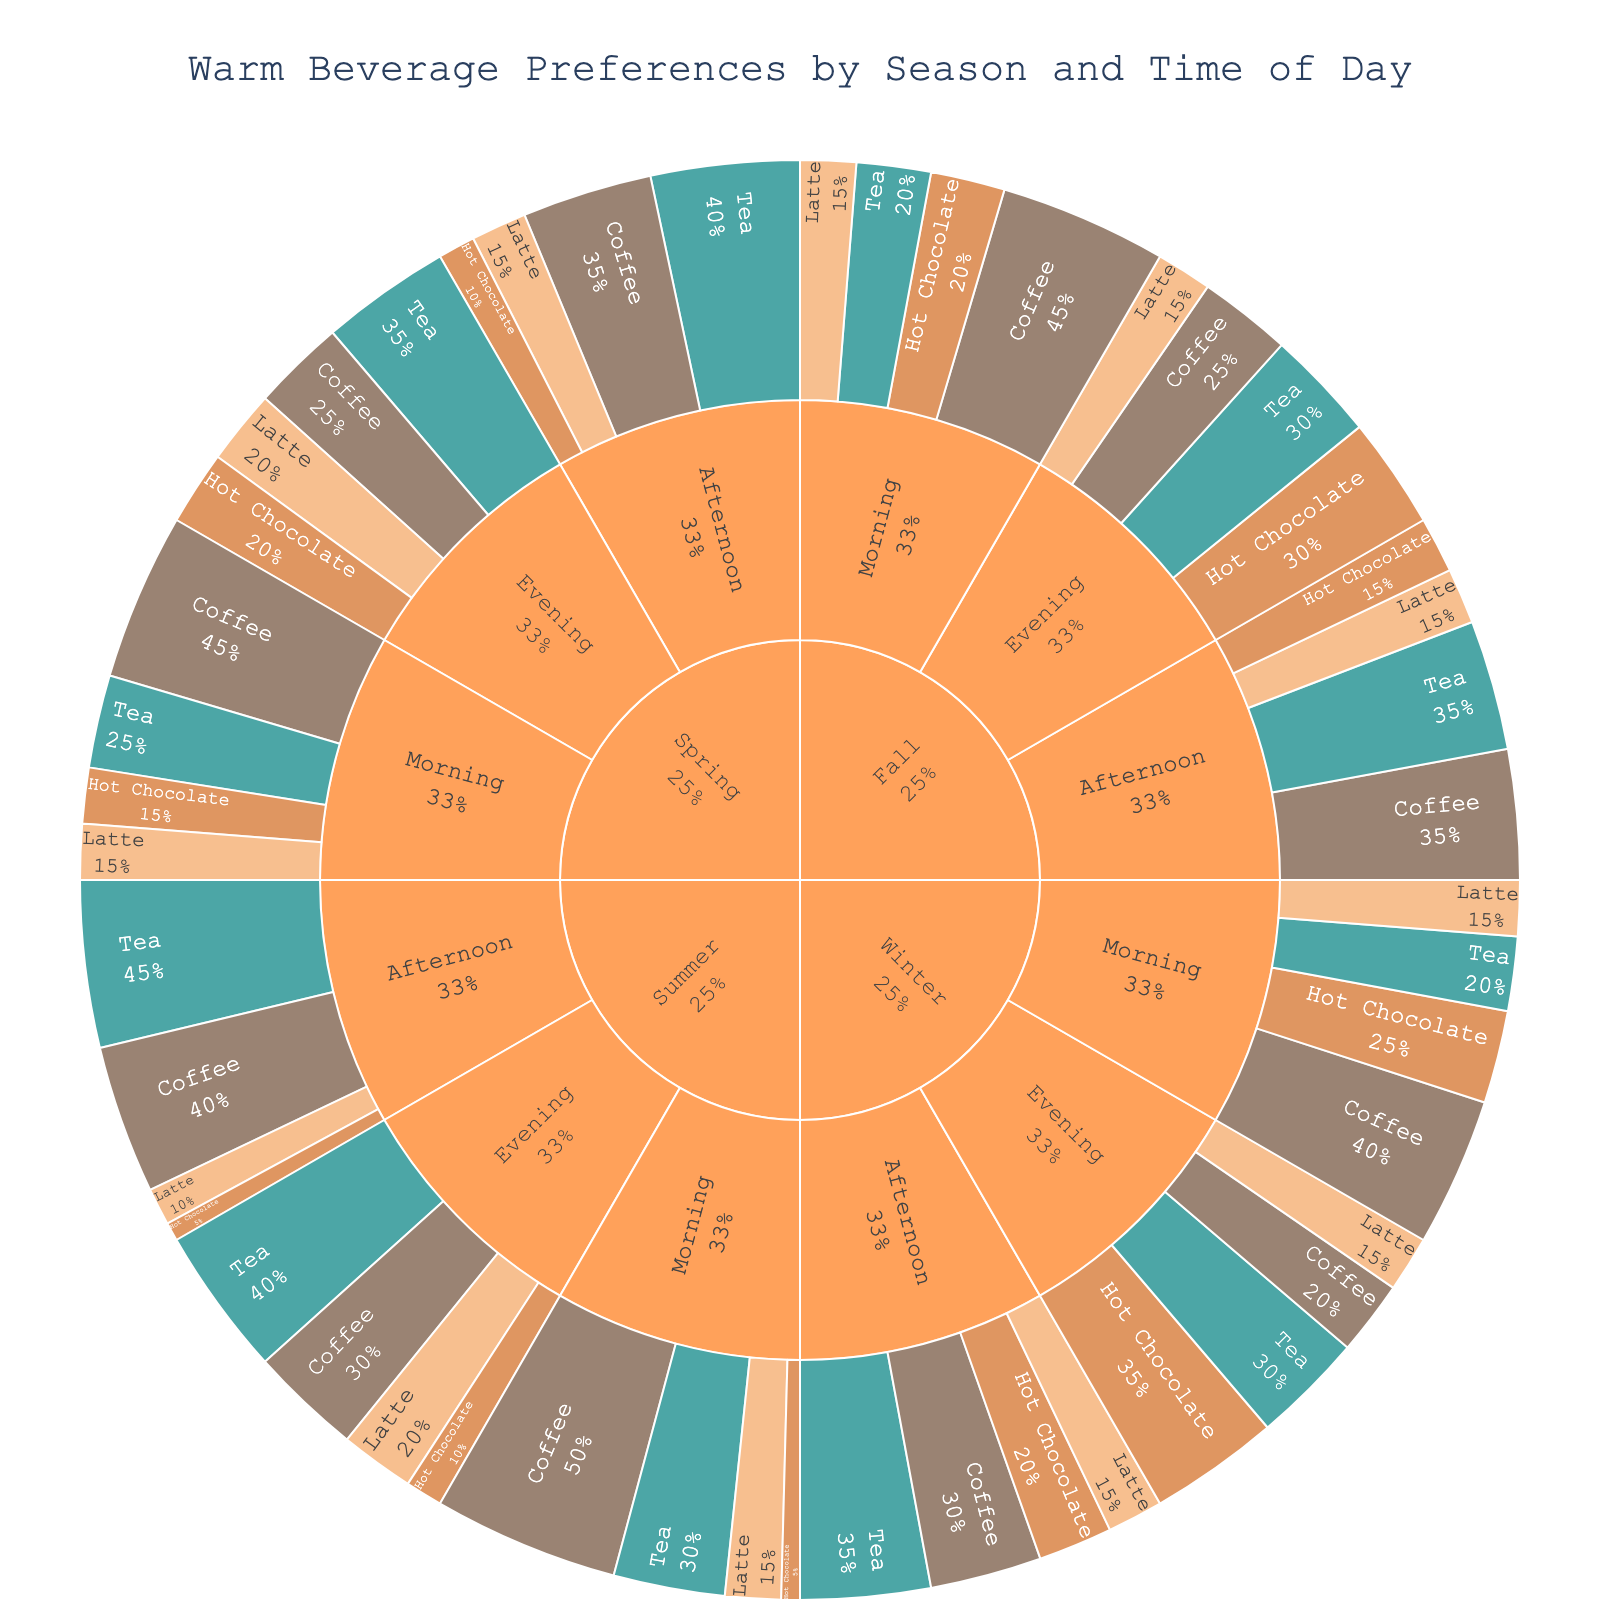What is the title of the sunburst plot? The title is usually located at the top center of the plot, and in this case, it reads 'Warm Beverage Preferences by Season and Time of Day'.
Answer: Warm Beverage Preferences by Season and Time of Day Which season has the highest percentage of Coffee drinkers in the morning? By examining the sunburst plot, look for the 'Morning' section under each 'Season'. Then identify which morning section has the largest percentage allocated to 'Coffee'.
Answer: Summer What is the total percentage of Hot Chocolate preferences in Winter? Locate the 'Winter' section and sum the percentages of Hot Chocolate for Morning (25%), Afternoon (20%), and Evening (35%). The calculation is 25% + 20% + 35% = 80%.
Answer: 80% Which beverage is least preferred in the Summer evening? Within the 'Summer' -> 'Evening' section, check the percentages for all beverages and identify the one with the lowest value.
Answer: Hot Chocolate How does the preference for Tea in the afternoon change from Winter to Summer? Compare the 'Afternoon' breakdown for 'Tea' between Winter (35%) and Summer (45%) to determine the difference.
Answer: It increases by 10% Which combination of season and time of day shows the highest preference for Latte? Explore all sections and observe the Latte percentages to find the highest value, noting both the season and time of day.
Answer: Spring Evening In which season and time of day does Coffee have the smallest percentage of preference? Investigate the Coffee percentages in all season-time combinations and identify the smallest one.
Answer: Winter Evening What is the average percentage of Tea drinkers during the afternoon across all seasons? Calculate the average by summing the Tea percentages for afternoons in Winter (35%), Spring (40%), Summer (45%), and Fall (35%), then divide by the number of seasons. (35% + 40% + 45% + 35%) / 4 = 38.75%.
Answer: 38.75% Which beverage shows a consistent 15% preference across all times of the day in any season? Look for a beverage in any particular season that has a percentage of 15% in Morning, Afternoon, and Evening segments.
Answer: Latte in Winter 